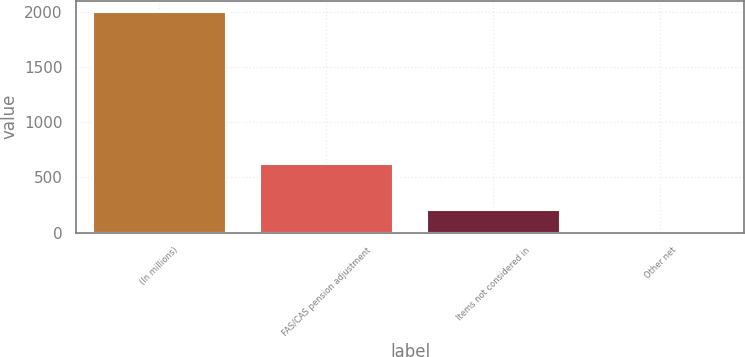<chart> <loc_0><loc_0><loc_500><loc_500><bar_chart><fcel>(In millions)<fcel>FAS/CAS pension adjustment<fcel>Items not considered in<fcel>Other net<nl><fcel>2005<fcel>626<fcel>206.8<fcel>7<nl></chart> 